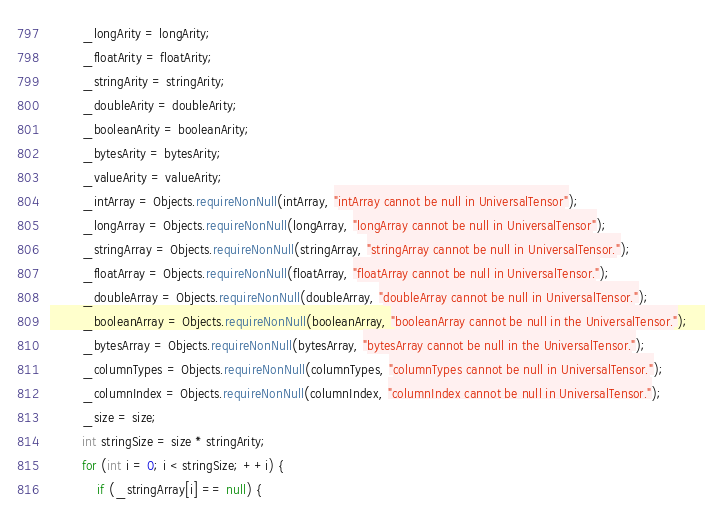<code> <loc_0><loc_0><loc_500><loc_500><_Java_>        _longArity = longArity;
        _floatArity = floatArity;
        _stringArity = stringArity;
        _doubleArity = doubleArity;
        _booleanArity = booleanArity;
        _bytesArity = bytesArity;
        _valueArity = valueArity;
        _intArray = Objects.requireNonNull(intArray, "intArray cannot be null in UniversalTensor");
        _longArray = Objects.requireNonNull(longArray, "longArray cannot be null in UniversalTensor");
        _stringArray = Objects.requireNonNull(stringArray, "stringArray cannot be null in UniversalTensor.");
        _floatArray = Objects.requireNonNull(floatArray, "floatArray cannot be null in UniversalTensor.");
        _doubleArray = Objects.requireNonNull(doubleArray, "doubleArray cannot be null in UniversalTensor.");
        _booleanArray = Objects.requireNonNull(booleanArray, "booleanArray cannot be null in the UniversalTensor.");
        _bytesArray = Objects.requireNonNull(bytesArray, "bytesArray cannot be null in the UniversalTensor.");
        _columnTypes = Objects.requireNonNull(columnTypes, "columnTypes cannot be null in UniversalTensor.");
        _columnIndex = Objects.requireNonNull(columnIndex, "columnIndex cannot be null in UniversalTensor.");
        _size = size;
        int stringSize = size * stringArity;
        for (int i = 0; i < stringSize; ++i) {
            if (_stringArray[i] == null) {</code> 